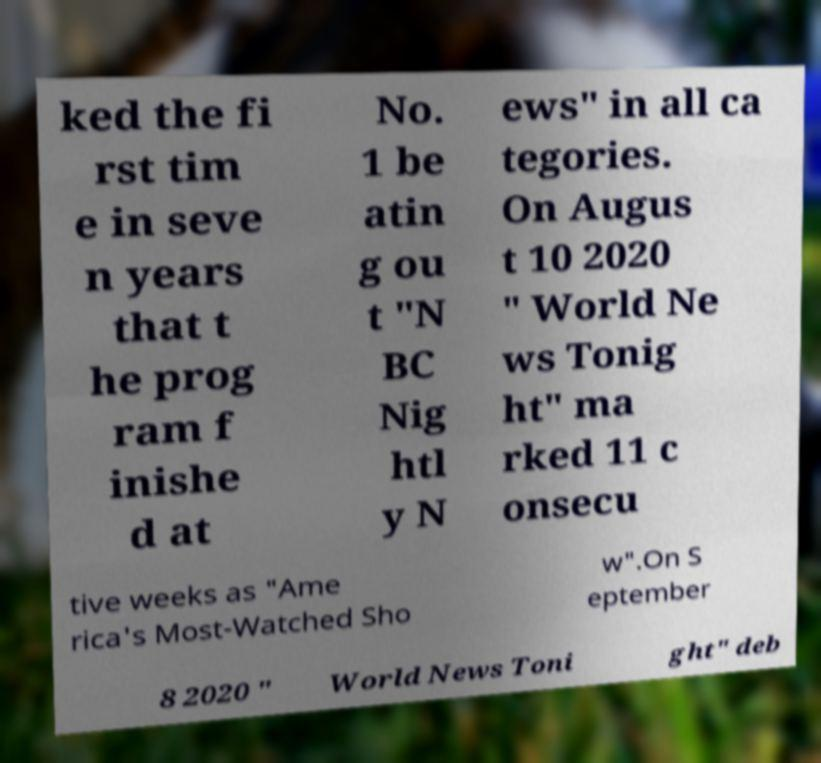Please identify and transcribe the text found in this image. ked the fi rst tim e in seve n years that t he prog ram f inishe d at No. 1 be atin g ou t "N BC Nig htl y N ews" in all ca tegories. On Augus t 10 2020 " World Ne ws Tonig ht" ma rked 11 c onsecu tive weeks as "Ame rica's Most-Watched Sho w".On S eptember 8 2020 " World News Toni ght" deb 